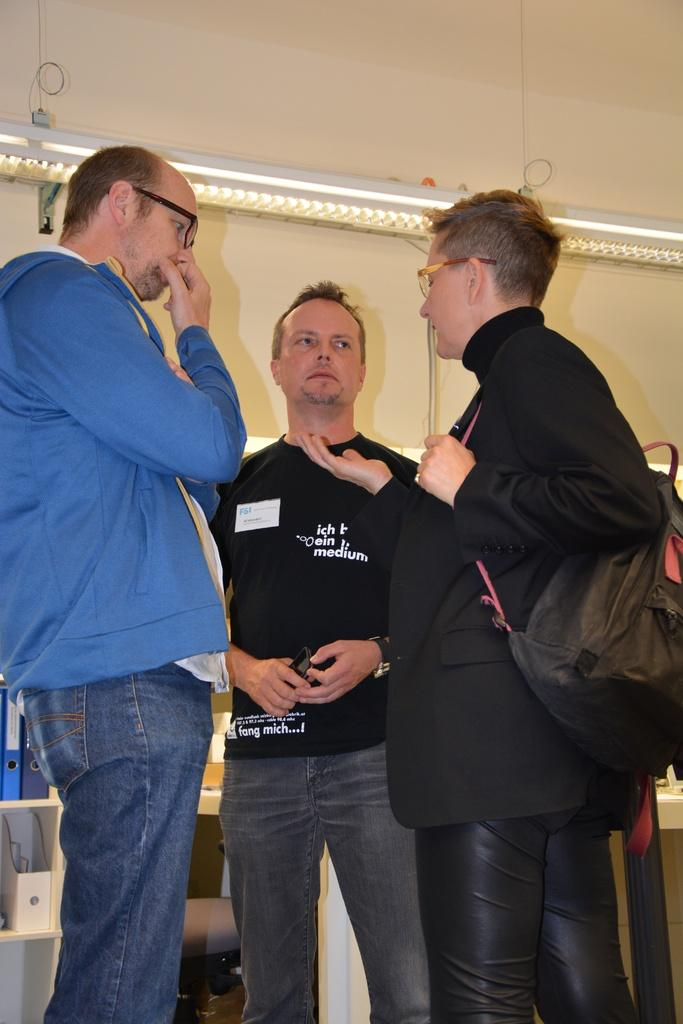How many people are present in the image? There are three people standing in the image. Can you describe what one of the people is holding? One of the people is holding a bag on his shoulder. What can be seen in the background of the image? There is a wall in the background of the image. What type of beetle can be seen crawling on the wall in the image? There is no beetle present in the image; only the three people and the wall are visible. What type of mask is being worn by one of the people in the image? There is no mask present in the image; none of the people are wearing masks. 